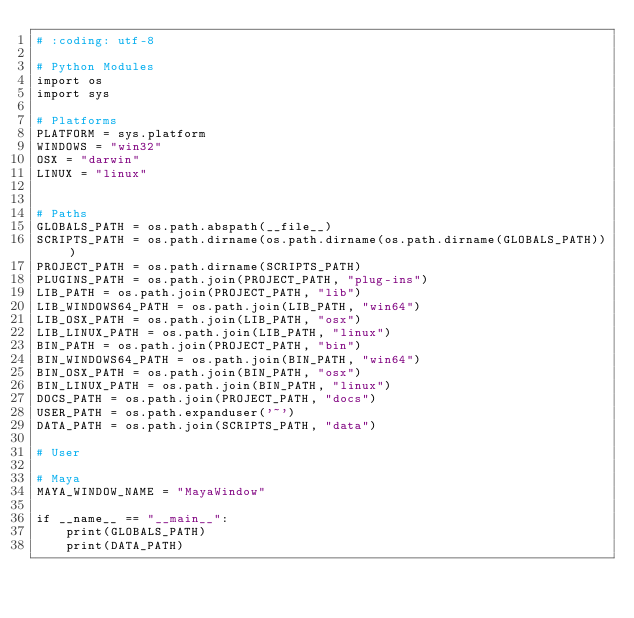<code> <loc_0><loc_0><loc_500><loc_500><_Python_># :coding: utf-8

# Python Modules
import os
import sys

# Platforms
PLATFORM = sys.platform
WINDOWS = "win32"
OSX = "darwin"
LINUX = "linux"


# Paths
GLOBALS_PATH = os.path.abspath(__file__)
SCRIPTS_PATH = os.path.dirname(os.path.dirname(os.path.dirname(GLOBALS_PATH)))
PROJECT_PATH = os.path.dirname(SCRIPTS_PATH)
PLUGINS_PATH = os.path.join(PROJECT_PATH, "plug-ins")
LIB_PATH = os.path.join(PROJECT_PATH, "lib")
LIB_WINDOWS64_PATH = os.path.join(LIB_PATH, "win64")
LIB_OSX_PATH = os.path.join(LIB_PATH, "osx")
LIB_LINUX_PATH = os.path.join(LIB_PATH, "linux")
BIN_PATH = os.path.join(PROJECT_PATH, "bin")
BIN_WINDOWS64_PATH = os.path.join(BIN_PATH, "win64")
BIN_OSX_PATH = os.path.join(BIN_PATH, "osx")
BIN_LINUX_PATH = os.path.join(BIN_PATH, "linux")
DOCS_PATH = os.path.join(PROJECT_PATH, "docs")
USER_PATH = os.path.expanduser('~')
DATA_PATH = os.path.join(SCRIPTS_PATH, "data")

# User

# Maya
MAYA_WINDOW_NAME = "MayaWindow"

if __name__ == "__main__":
    print(GLOBALS_PATH)
    print(DATA_PATH)


</code> 